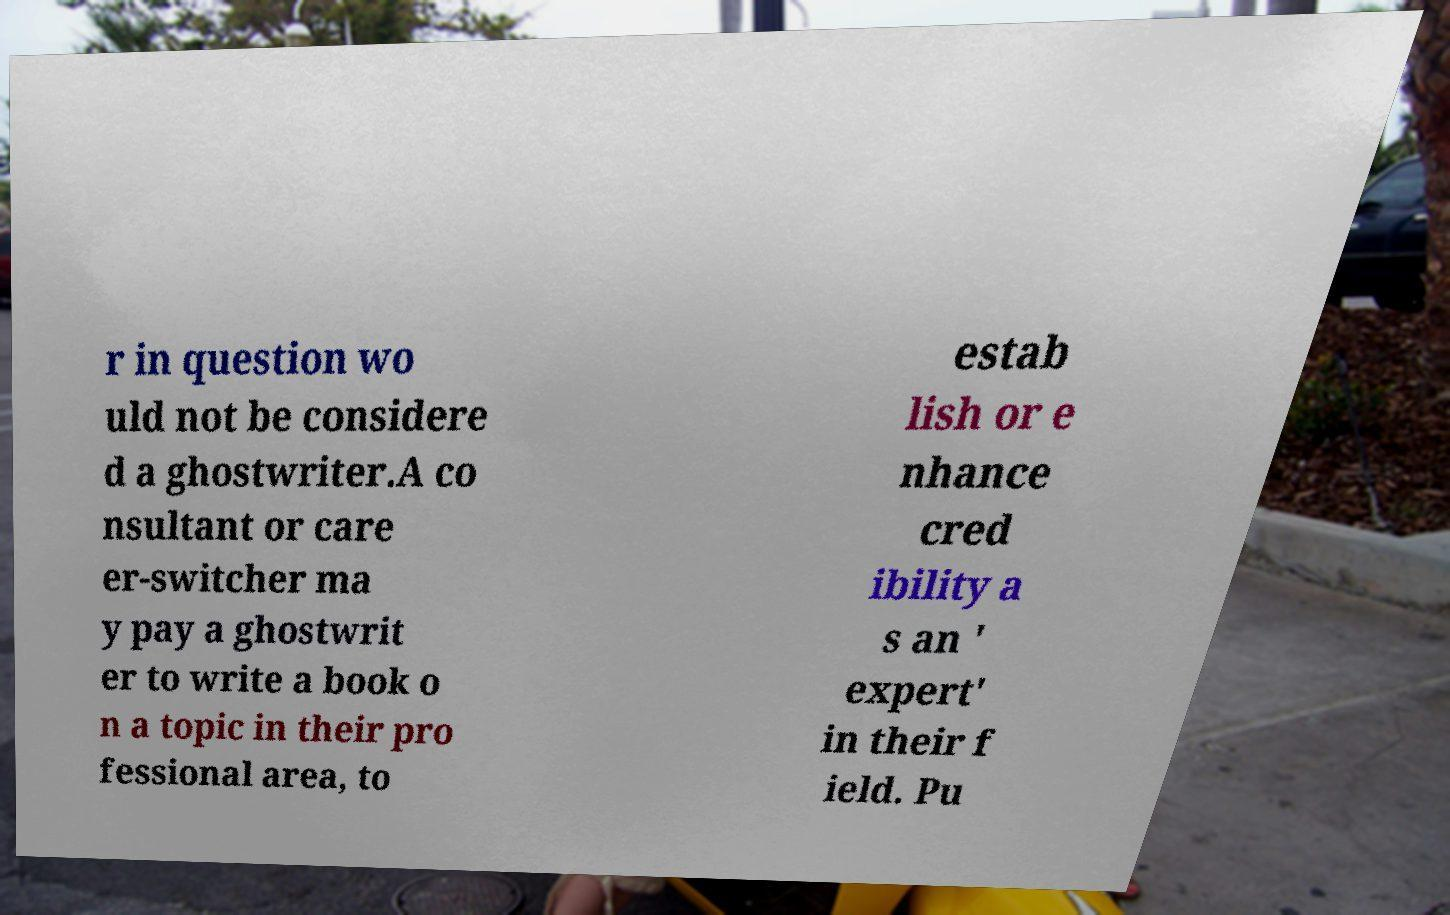There's text embedded in this image that I need extracted. Can you transcribe it verbatim? r in question wo uld not be considere d a ghostwriter.A co nsultant or care er-switcher ma y pay a ghostwrit er to write a book o n a topic in their pro fessional area, to estab lish or e nhance cred ibility a s an ' expert' in their f ield. Pu 